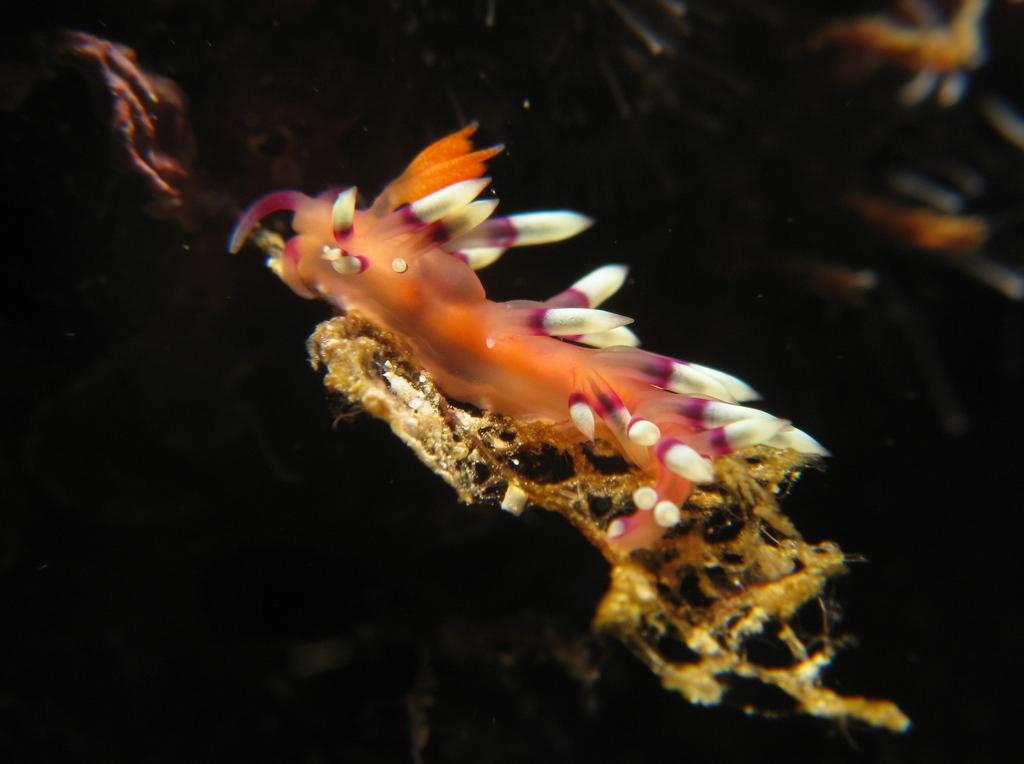What type of animal can be seen in the image? There is a water animal in the image. What type of exchange is taking place between the rail and the faucet in the image? There is no exchange, rail, or faucet present in the image. The image only features a water animal. 